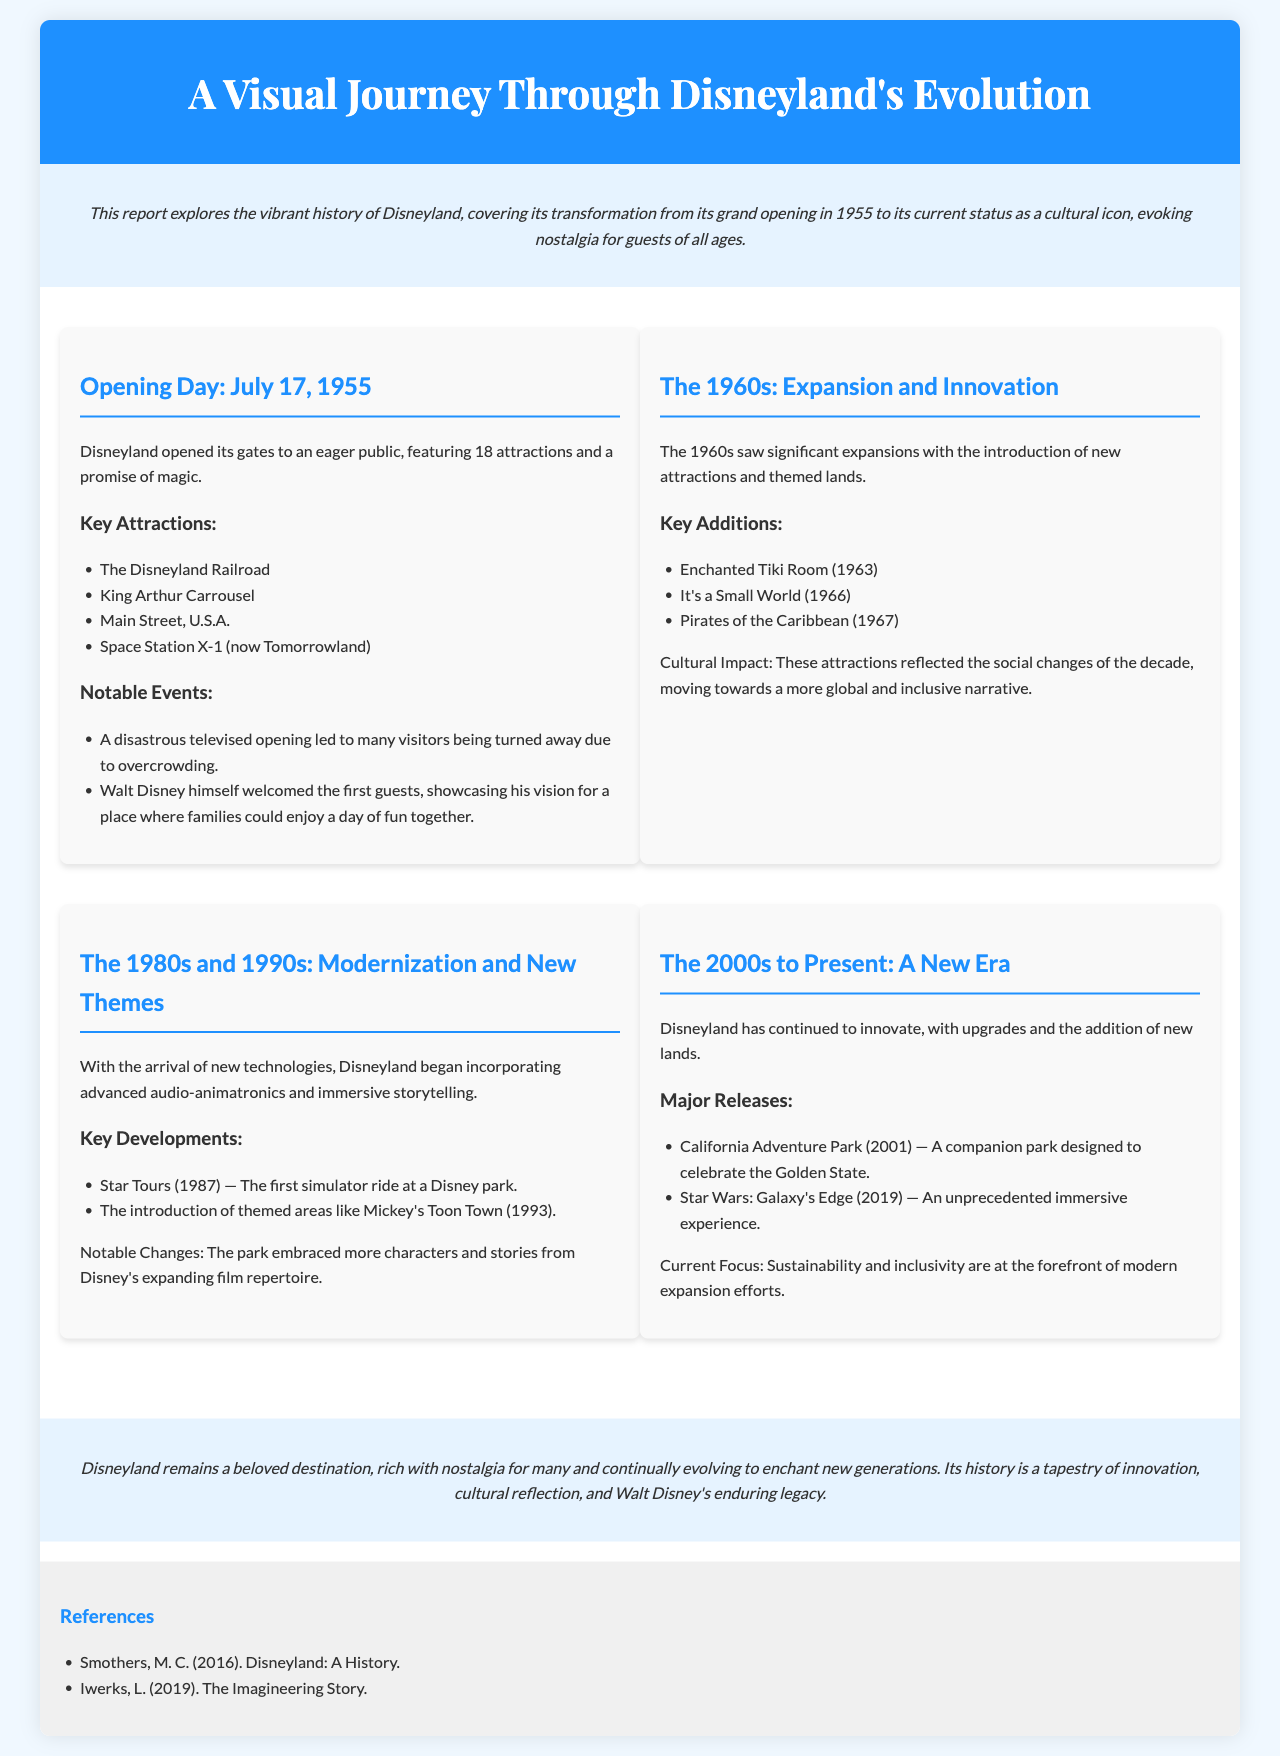What date did Disneyland open? The document states that Disneyland opened on July 17, 1955.
Answer: July 17, 1955 How many attractions were available on opening day? According to the document, Disneyland opened with 18 attractions.
Answer: 18 attractions What attraction was introduced in 1963? The document mentions that the Enchanted Tiki Room was introduced in 1963.
Answer: Enchanted Tiki Room What significant event occurred during the opening day? The document describes a disastrous televised opening that led to overcrowding.
Answer: Overcrowding Which themed area was introduced in 1993? The document notes that Mickey's Toon Town was introduced in 1993.
Answer: Mickey's Toon Town What major park opened in 2001? According to the document, California Adventure Park opened in 2001.
Answer: California Adventure Park What is the focus of Disneyland's modern expansion efforts? The document states that sustainability and inclusivity are the current focus.
Answer: Sustainability and inclusivity Which attraction is highlighted as an unprecedented immersive experience? The document refers to Star Wars: Galaxy's Edge as an unprecedented immersive experience.
Answer: Star Wars: Galaxy's Edge What was the cultural impact explored in the 1960s section? The document explains that the attractions reflected social changes, promoting a more global narrative.
Answer: A more global narrative 